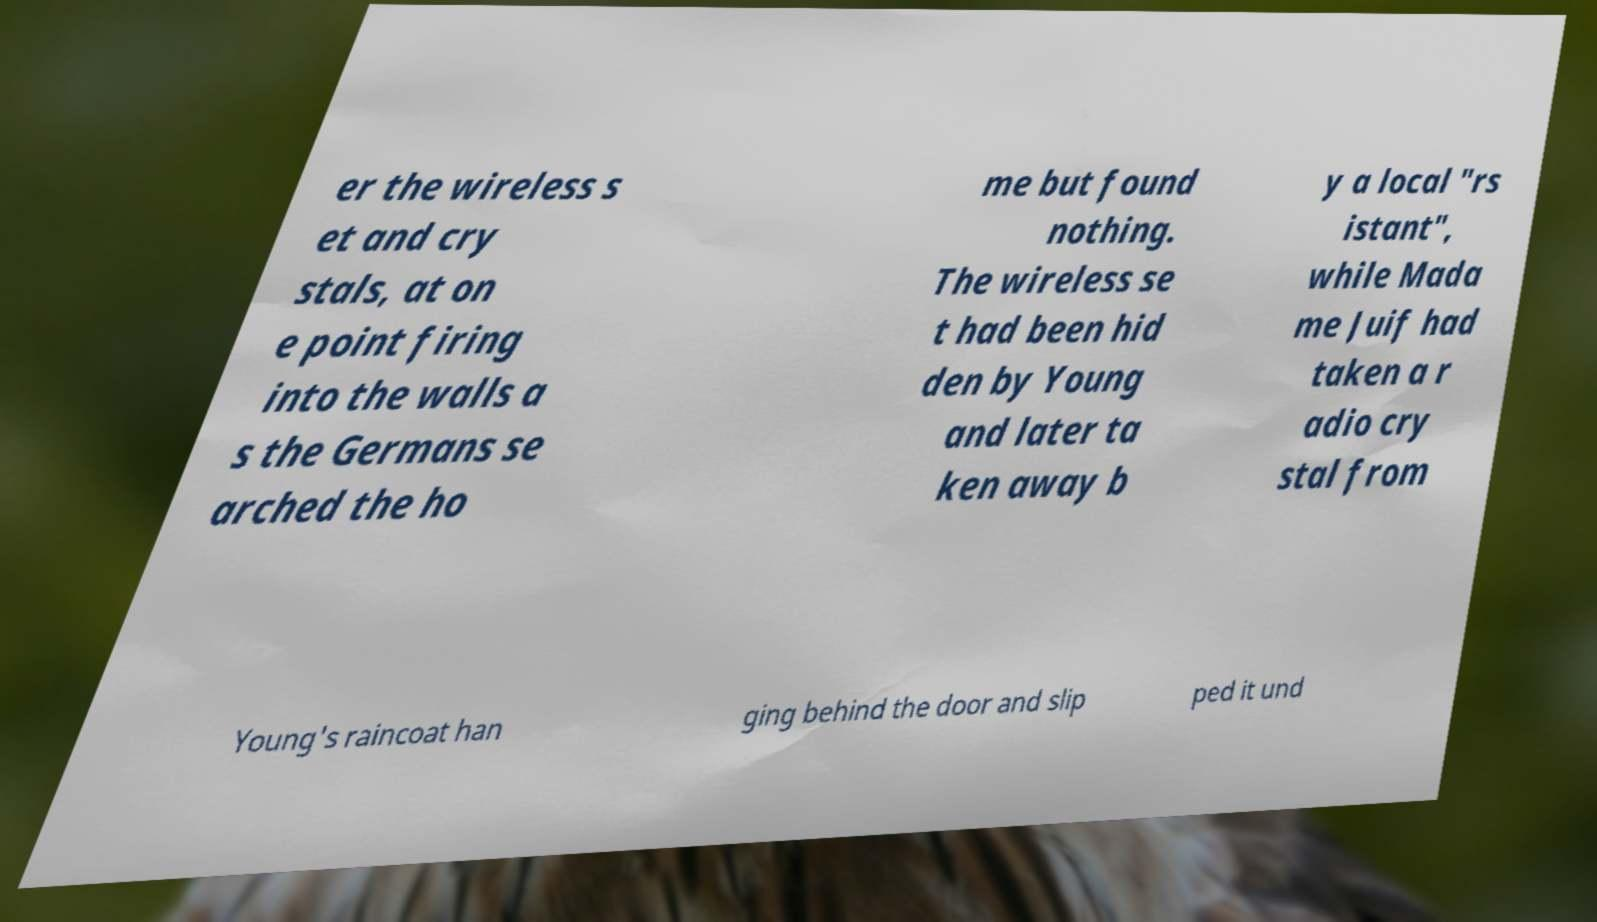Can you accurately transcribe the text from the provided image for me? er the wireless s et and cry stals, at on e point firing into the walls a s the Germans se arched the ho me but found nothing. The wireless se t had been hid den by Young and later ta ken away b y a local "rs istant", while Mada me Juif had taken a r adio cry stal from Young's raincoat han ging behind the door and slip ped it und 